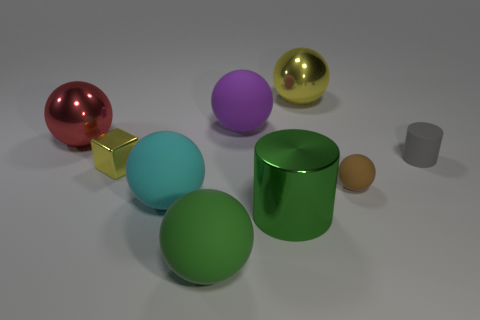Subtract all cyan rubber balls. How many balls are left? 5 Subtract 3 spheres. How many spheres are left? 3 Subtract all purple spheres. How many spheres are left? 5 Subtract all yellow balls. Subtract all cyan cylinders. How many balls are left? 5 Add 1 cyan objects. How many objects exist? 10 Subtract all cylinders. How many objects are left? 7 Add 6 large blue spheres. How many large blue spheres exist? 6 Subtract 1 brown spheres. How many objects are left? 8 Subtract all large green spheres. Subtract all brown balls. How many objects are left? 7 Add 5 tiny brown balls. How many tiny brown balls are left? 6 